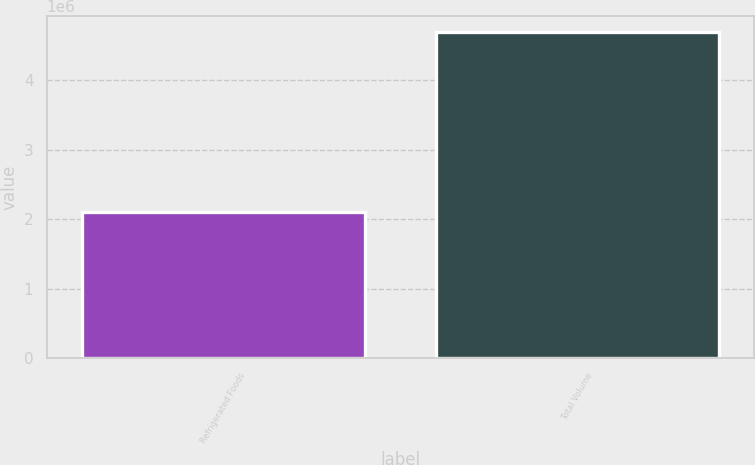Convert chart to OTSL. <chart><loc_0><loc_0><loc_500><loc_500><bar_chart><fcel>Refrigerated Foods<fcel>Total Volume<nl><fcel>2.09995e+06<fcel>4.69003e+06<nl></chart> 